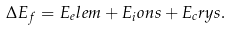Convert formula to latex. <formula><loc_0><loc_0><loc_500><loc_500>\Delta E _ { f } = E _ { e } l e m + E _ { i } o n s + E _ { c } r y s .</formula> 